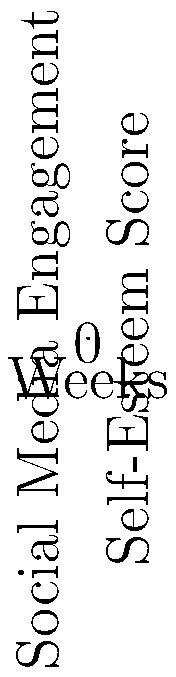As a male model in the fashion industry, you've been tracking your social media engagement and self-esteem scores over seven weeks. The line graph shows the relationship between your weekly social media engagement (blue line, left y-axis) and self-esteem scores (red line, right y-axis). The scatter plot (purple dots) represents the correlation between these two variables.

Based on the data presented in the graph, what can you conclude about the relationship between your social media engagement and self-esteem? Calculate the Pearson correlation coefficient (r) to support your answer, rounding to two decimal places. To analyze the relationship between social media engagement and self-esteem, we need to follow these steps:

1. Observe the trends in the line graph:
   - Social media engagement (blue line) is increasing over time.
   - Self-esteem scores (red line) are decreasing over time.

2. Look at the scatter plot (purple dots):
   - There appears to be a negative relationship between social media engagement and self-esteem.

3. Calculate the Pearson correlation coefficient (r) to quantify this relationship:

   a. First, we need to calculate the means of x (social media engagement) and y (self-esteem scores):
      $\bar{x} = \frac{100 + 250 + 400 + 600 + 850 + 1100 + 1400}{7} = 671.43$
      $\bar{y} = \frac{7.5 + 7.2 + 6.8 + 6.5 + 6.2 + 5.8 + 5.5}{7} = 6.5$

   b. Calculate the numerator of the correlation coefficient:
      $\sum_{i=1}^{n} (x_i - \bar{x})(y_i - \bar{y}) = -1,244,285.71$

   c. Calculate the denominator:
      $\sqrt{\sum_{i=1}^{n} (x_i - \bar{x})^2 \sum_{i=1}^{n} (y_i - \bar{y})^2} = 1,259,649.59$

   d. Divide the numerator by the denominator:
      $r = \frac{-1,244,285.71}{1,259,649.59} = -0.9878$

4. Interpret the results:
   - The Pearson correlation coefficient of -0.99 indicates a very strong negative correlation between social media engagement and self-esteem.
   - As social media engagement increases, self-esteem tends to decrease, and vice versa.

This analysis suggests that there is a significant inverse relationship between your social media engagement and self-esteem levels. As you become more active on social media platforms, your self-esteem appears to decline, which could be related to the pressures and comparisons often associated with social media use in the modeling industry.
Answer: Strong negative correlation (r = -0.99) between social media engagement and self-esteem. 